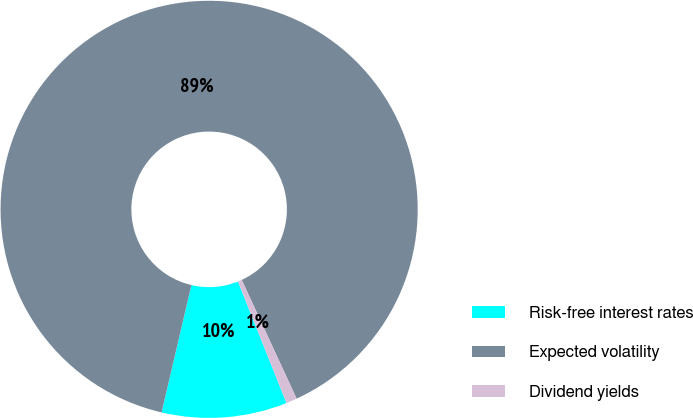Convert chart to OTSL. <chart><loc_0><loc_0><loc_500><loc_500><pie_chart><fcel>Risk-free interest rates<fcel>Expected volatility<fcel>Dividend yields<nl><fcel>9.71%<fcel>89.46%<fcel>0.84%<nl></chart> 